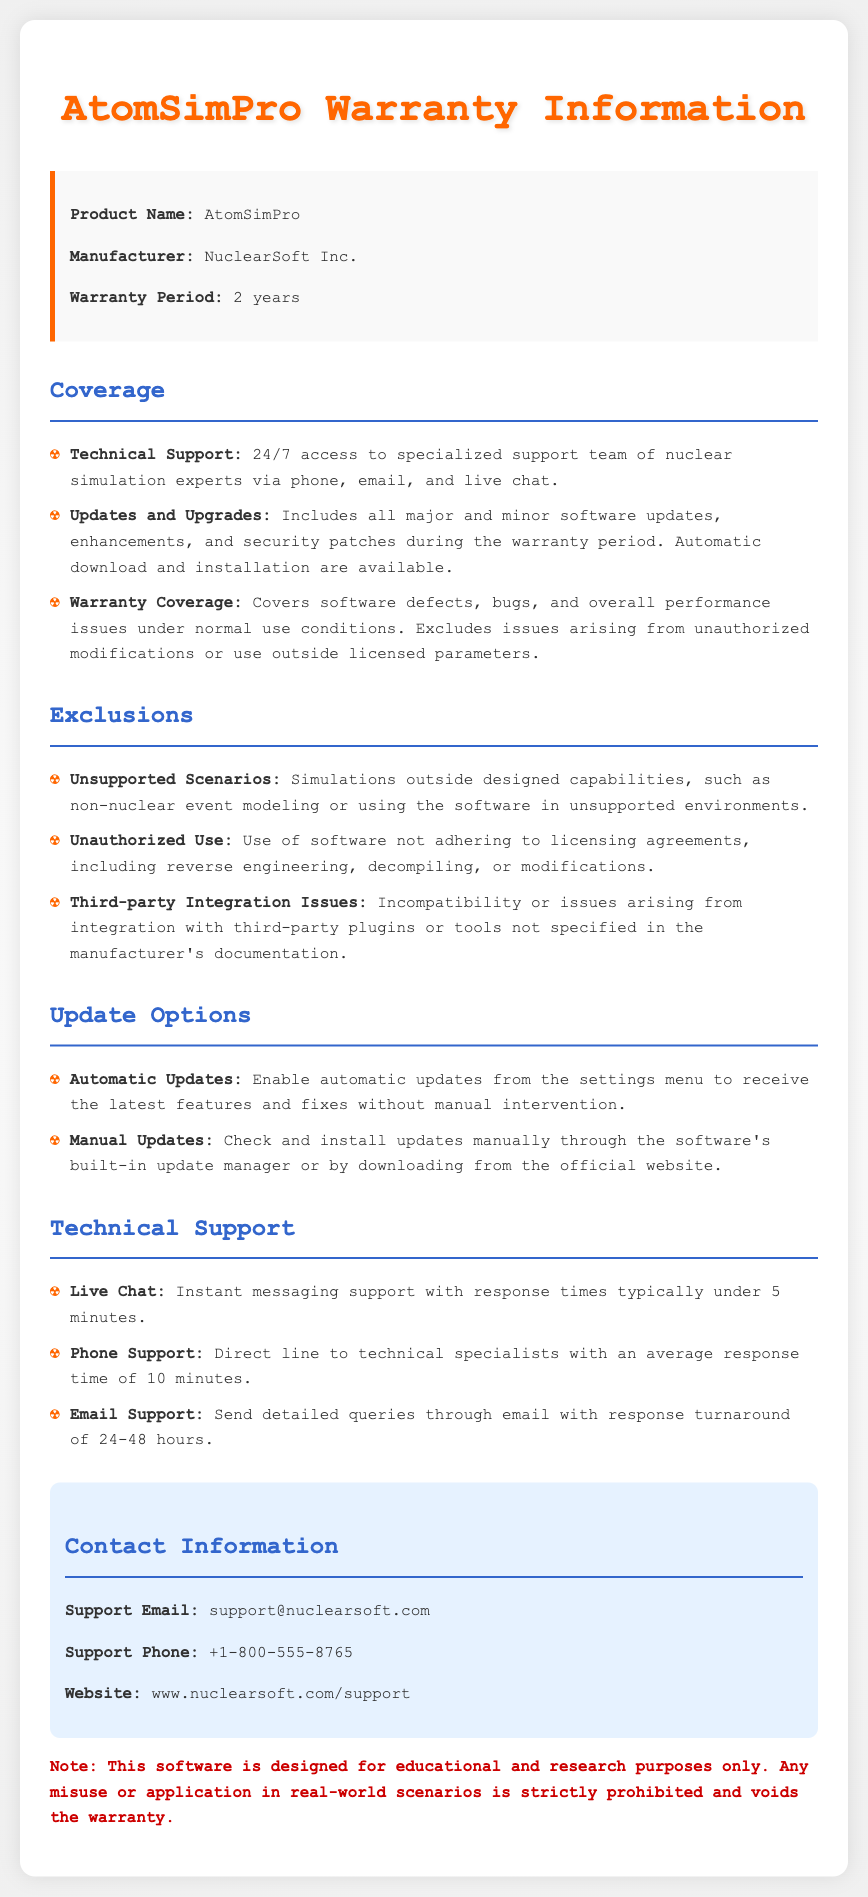What is the warranty period for AtomSimPro? The warranty period for AtomSimPro is specified in the document under the warranty details section.
Answer: 2 years Who is the manufacturer of AtomSimPro? The manufacturer is mentioned at the beginning of the document in the product details.
Answer: NuclearSoft Inc What kind of technical support is available? The document outlines the types of technical support offered, which can be found in the support section.
Answer: 24/7 access to specialized support team What does the warranty cover? The document lists items covered under warranty in the coverage section.
Answer: Software defects, bugs, and overall performance issues Are automatic updates available? The update options section addresses whether automatic updates are provided for the software.
Answer: Yes What is the average response time for phone support? The technical support section provides details related to response times for various support methods.
Answer: 10 minutes What would void the warranty? The document includes conditions that can void the warranty in the warnings section.
Answer: Misuse or application in real-world scenarios What is the support email for assistance? The contact information section lists how to get in touch with the support team, including email.
Answer: support@nuclearsoft.com 